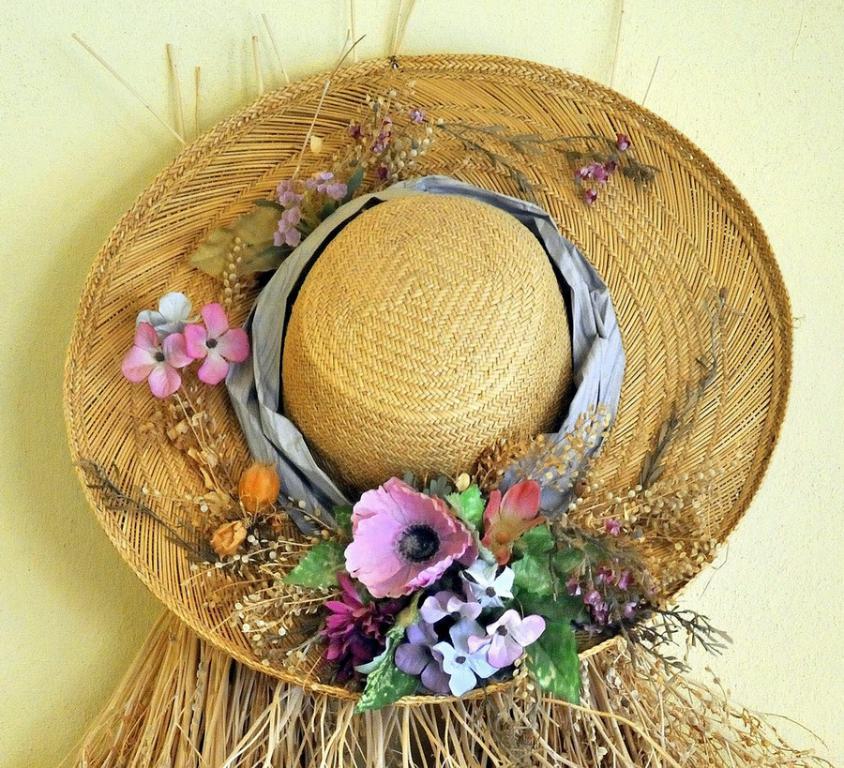How would you summarize this image in a sentence or two? In this image I can see a hat is attached to a wall. This hat is decorated with flowers and some other objects. 